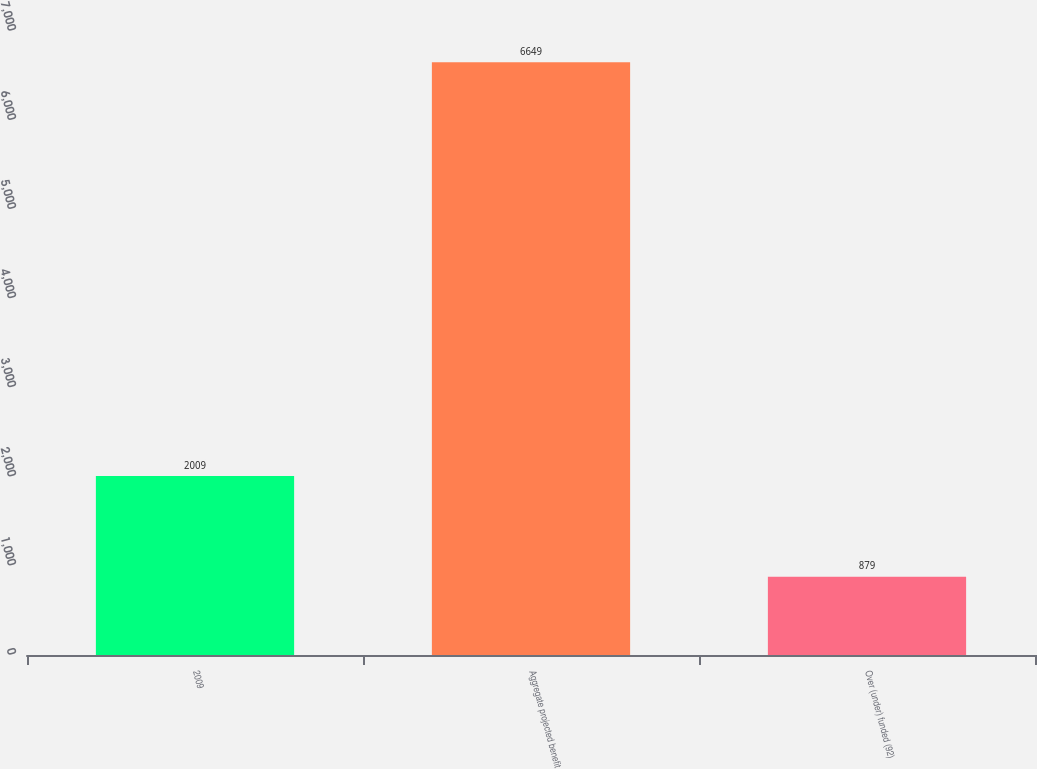<chart> <loc_0><loc_0><loc_500><loc_500><bar_chart><fcel>2009<fcel>Aggregate projected benefit<fcel>Over (under) funded (92)<nl><fcel>2009<fcel>6649<fcel>879<nl></chart> 